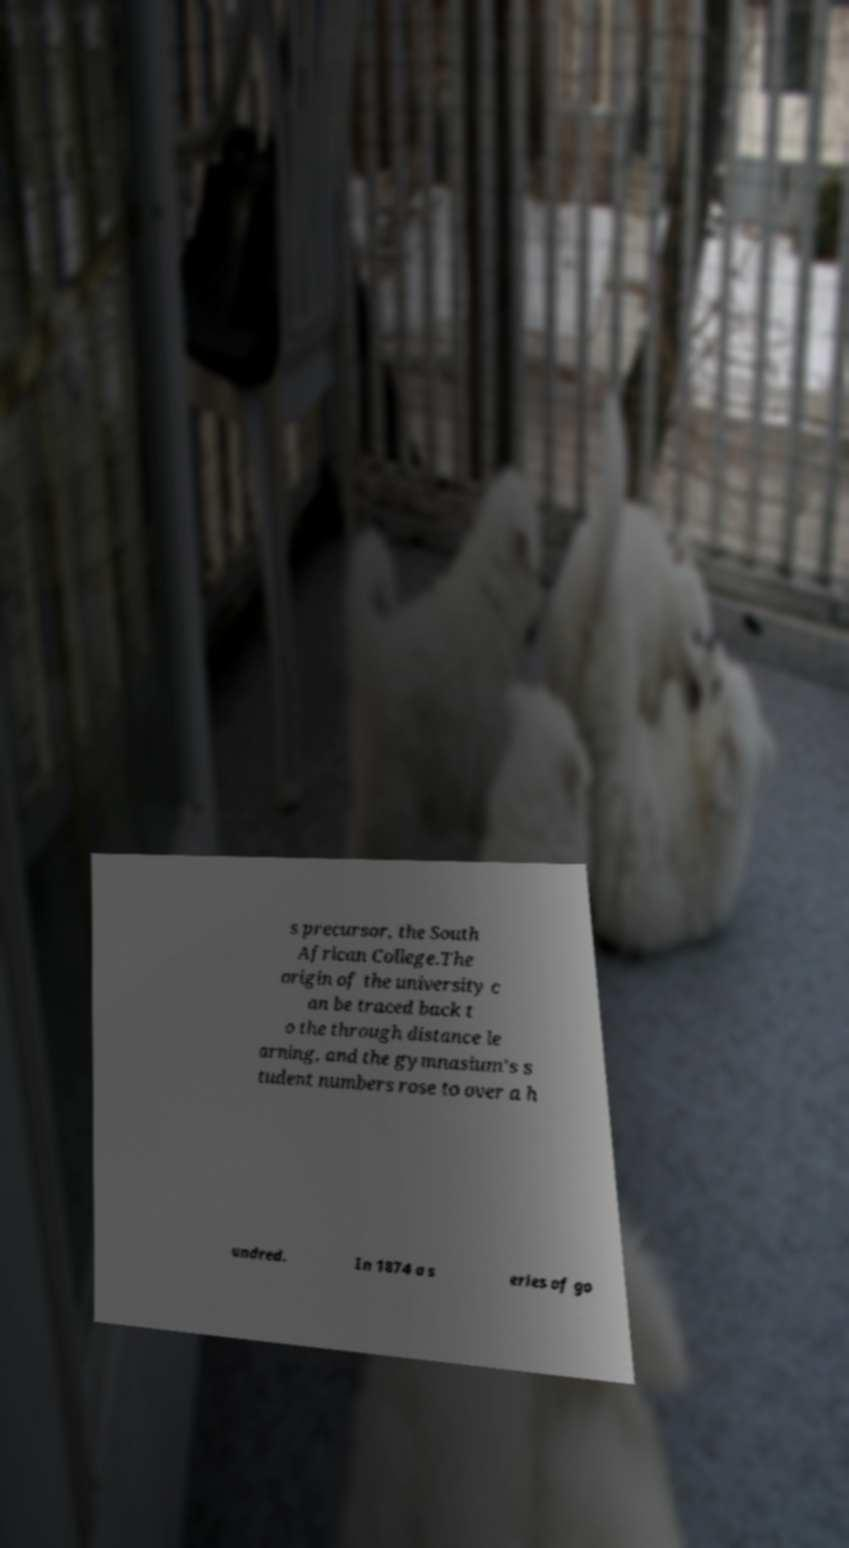Could you assist in decoding the text presented in this image and type it out clearly? s precursor, the South African College.The origin of the university c an be traced back t o the through distance le arning, and the gymnasium's s tudent numbers rose to over a h undred. In 1874 a s eries of go 